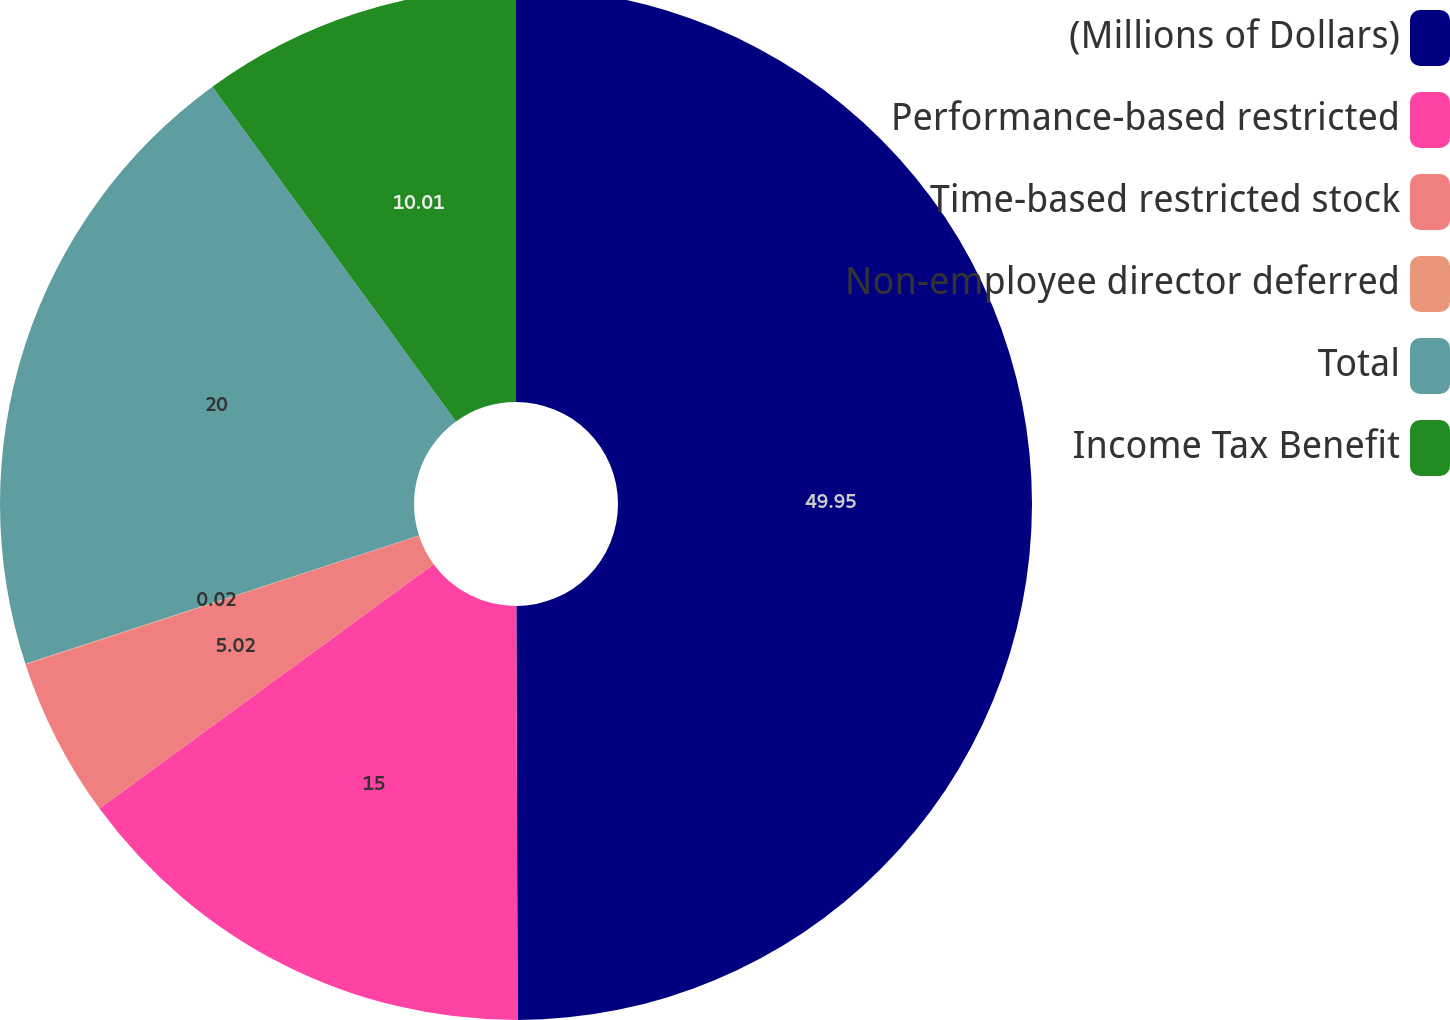<chart> <loc_0><loc_0><loc_500><loc_500><pie_chart><fcel>(Millions of Dollars)<fcel>Performance-based restricted<fcel>Time-based restricted stock<fcel>Non-employee director deferred<fcel>Total<fcel>Income Tax Benefit<nl><fcel>49.95%<fcel>15.0%<fcel>5.02%<fcel>0.02%<fcel>20.0%<fcel>10.01%<nl></chart> 